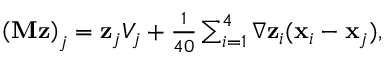<formula> <loc_0><loc_0><loc_500><loc_500>\begin{array} { r } { \left ( { M } { z } \right ) _ { j } = { z } _ { j } V _ { j } + \frac { 1 } { 4 0 } \sum _ { i = 1 } ^ { 4 } \nabla { z } _ { i } ( { x } _ { i } - { x } _ { j } ) , } \end{array}</formula> 